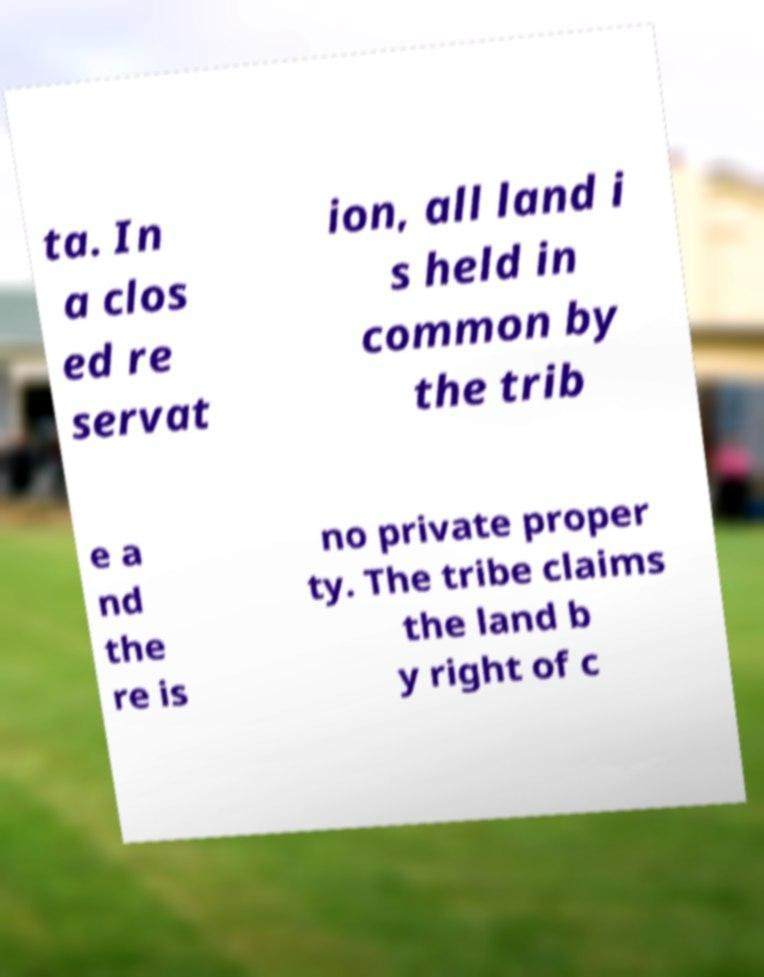Please identify and transcribe the text found in this image. ta. In a clos ed re servat ion, all land i s held in common by the trib e a nd the re is no private proper ty. The tribe claims the land b y right of c 